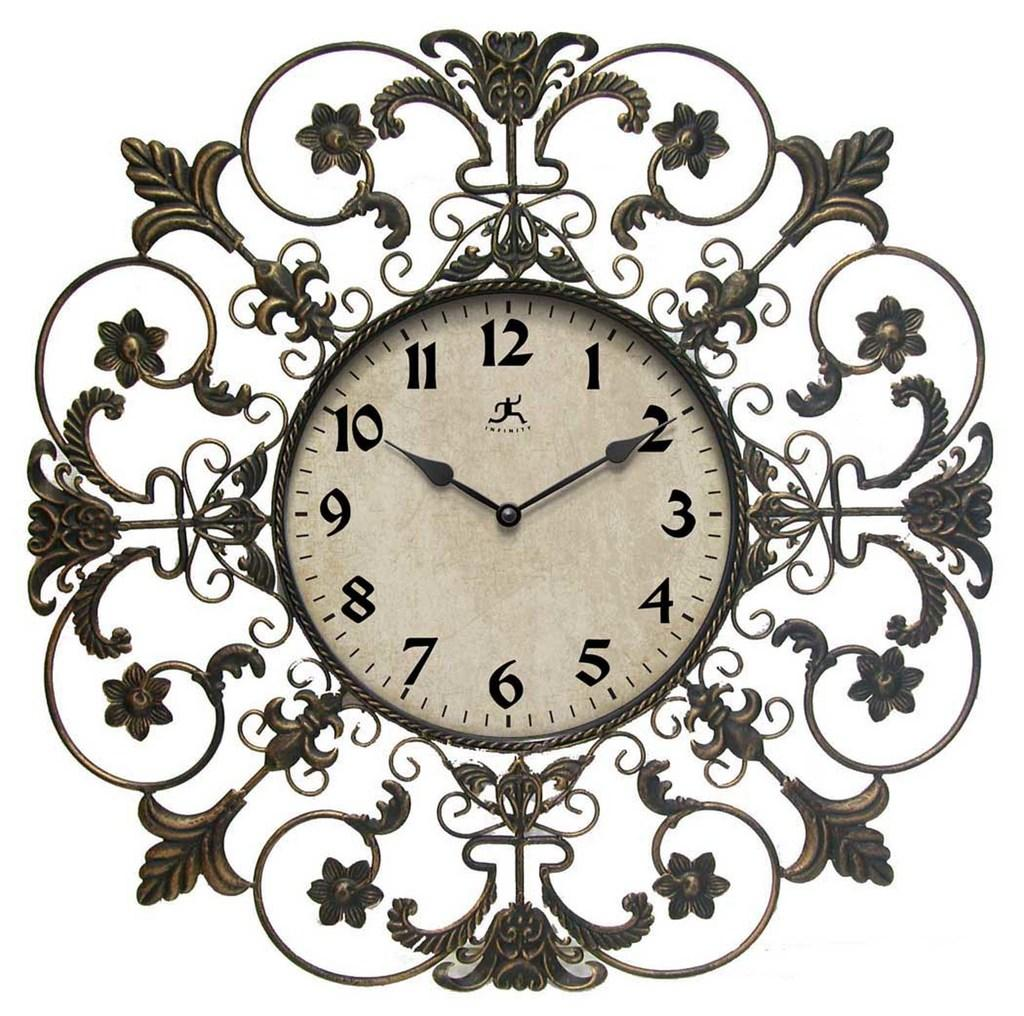<image>
Write a terse but informative summary of the picture. An ornate wall clock made by Infinity with flowers and vines decorating the exterior region. 